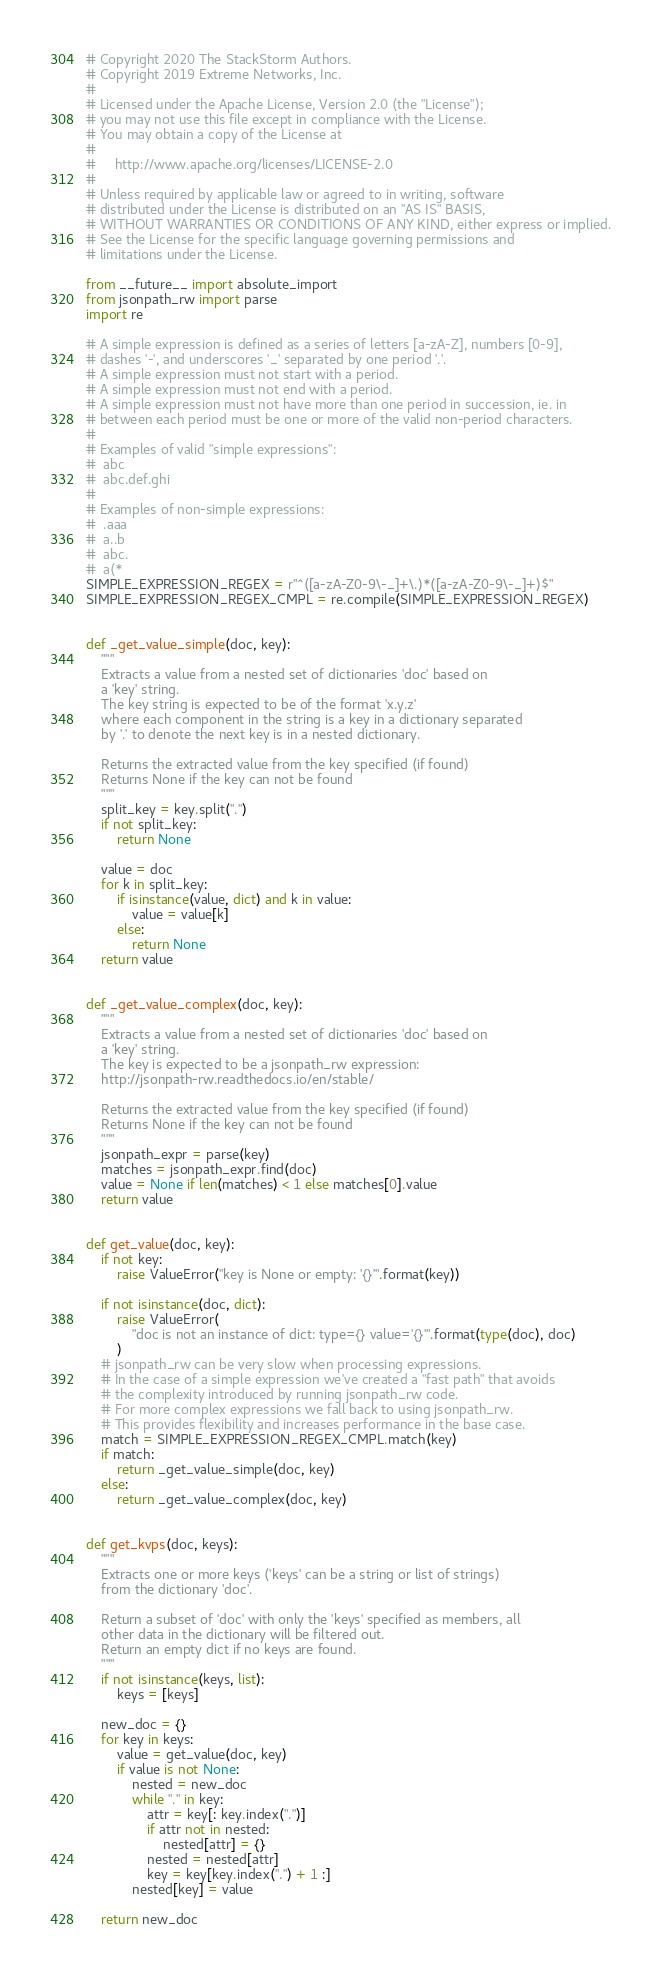Convert code to text. <code><loc_0><loc_0><loc_500><loc_500><_Python_># Copyright 2020 The StackStorm Authors.
# Copyright 2019 Extreme Networks, Inc.
#
# Licensed under the Apache License, Version 2.0 (the "License");
# you may not use this file except in compliance with the License.
# You may obtain a copy of the License at
#
#     http://www.apache.org/licenses/LICENSE-2.0
#
# Unless required by applicable law or agreed to in writing, software
# distributed under the License is distributed on an "AS IS" BASIS,
# WITHOUT WARRANTIES OR CONDITIONS OF ANY KIND, either express or implied.
# See the License for the specific language governing permissions and
# limitations under the License.

from __future__ import absolute_import
from jsonpath_rw import parse
import re

# A simple expression is defined as a series of letters [a-zA-Z], numbers [0-9],
# dashes '-', and underscores '_' separated by one period '.'.
# A simple expression must not start with a period.
# A simple expression must not end with a period.
# A simple expression must not have more than one period in succession, ie. in
# between each period must be one or more of the valid non-period characters.
#
# Examples of valid "simple expressions":
#  abc
#  abc.def.ghi
#
# Examples of non-simple expressions:
#  .aaa
#  a..b
#  abc.
#  a(*
SIMPLE_EXPRESSION_REGEX = r"^([a-zA-Z0-9\-_]+\.)*([a-zA-Z0-9\-_]+)$"
SIMPLE_EXPRESSION_REGEX_CMPL = re.compile(SIMPLE_EXPRESSION_REGEX)


def _get_value_simple(doc, key):
    """
    Extracts a value from a nested set of dictionaries 'doc' based on
    a 'key' string.
    The key string is expected to be of the format 'x.y.z'
    where each component in the string is a key in a dictionary separated
    by '.' to denote the next key is in a nested dictionary.

    Returns the extracted value from the key specified (if found)
    Returns None if the key can not be found
    """
    split_key = key.split(".")
    if not split_key:
        return None

    value = doc
    for k in split_key:
        if isinstance(value, dict) and k in value:
            value = value[k]
        else:
            return None
    return value


def _get_value_complex(doc, key):
    """
    Extracts a value from a nested set of dictionaries 'doc' based on
    a 'key' string.
    The key is expected to be a jsonpath_rw expression:
    http://jsonpath-rw.readthedocs.io/en/stable/

    Returns the extracted value from the key specified (if found)
    Returns None if the key can not be found
    """
    jsonpath_expr = parse(key)
    matches = jsonpath_expr.find(doc)
    value = None if len(matches) < 1 else matches[0].value
    return value


def get_value(doc, key):
    if not key:
        raise ValueError("key is None or empty: '{}'".format(key))

    if not isinstance(doc, dict):
        raise ValueError(
            "doc is not an instance of dict: type={} value='{}'".format(type(doc), doc)
        )
    # jsonpath_rw can be very slow when processing expressions.
    # In the case of a simple expression we've created a "fast path" that avoids
    # the complexity introduced by running jsonpath_rw code.
    # For more complex expressions we fall back to using jsonpath_rw.
    # This provides flexibility and increases performance in the base case.
    match = SIMPLE_EXPRESSION_REGEX_CMPL.match(key)
    if match:
        return _get_value_simple(doc, key)
    else:
        return _get_value_complex(doc, key)


def get_kvps(doc, keys):
    """
    Extracts one or more keys ('keys' can be a string or list of strings)
    from the dictionary 'doc'.

    Return a subset of 'doc' with only the 'keys' specified as members, all
    other data in the dictionary will be filtered out.
    Return an empty dict if no keys are found.
    """
    if not isinstance(keys, list):
        keys = [keys]

    new_doc = {}
    for key in keys:
        value = get_value(doc, key)
        if value is not None:
            nested = new_doc
            while "." in key:
                attr = key[: key.index(".")]
                if attr not in nested:
                    nested[attr] = {}
                nested = nested[attr]
                key = key[key.index(".") + 1 :]
            nested[key] = value

    return new_doc
</code> 